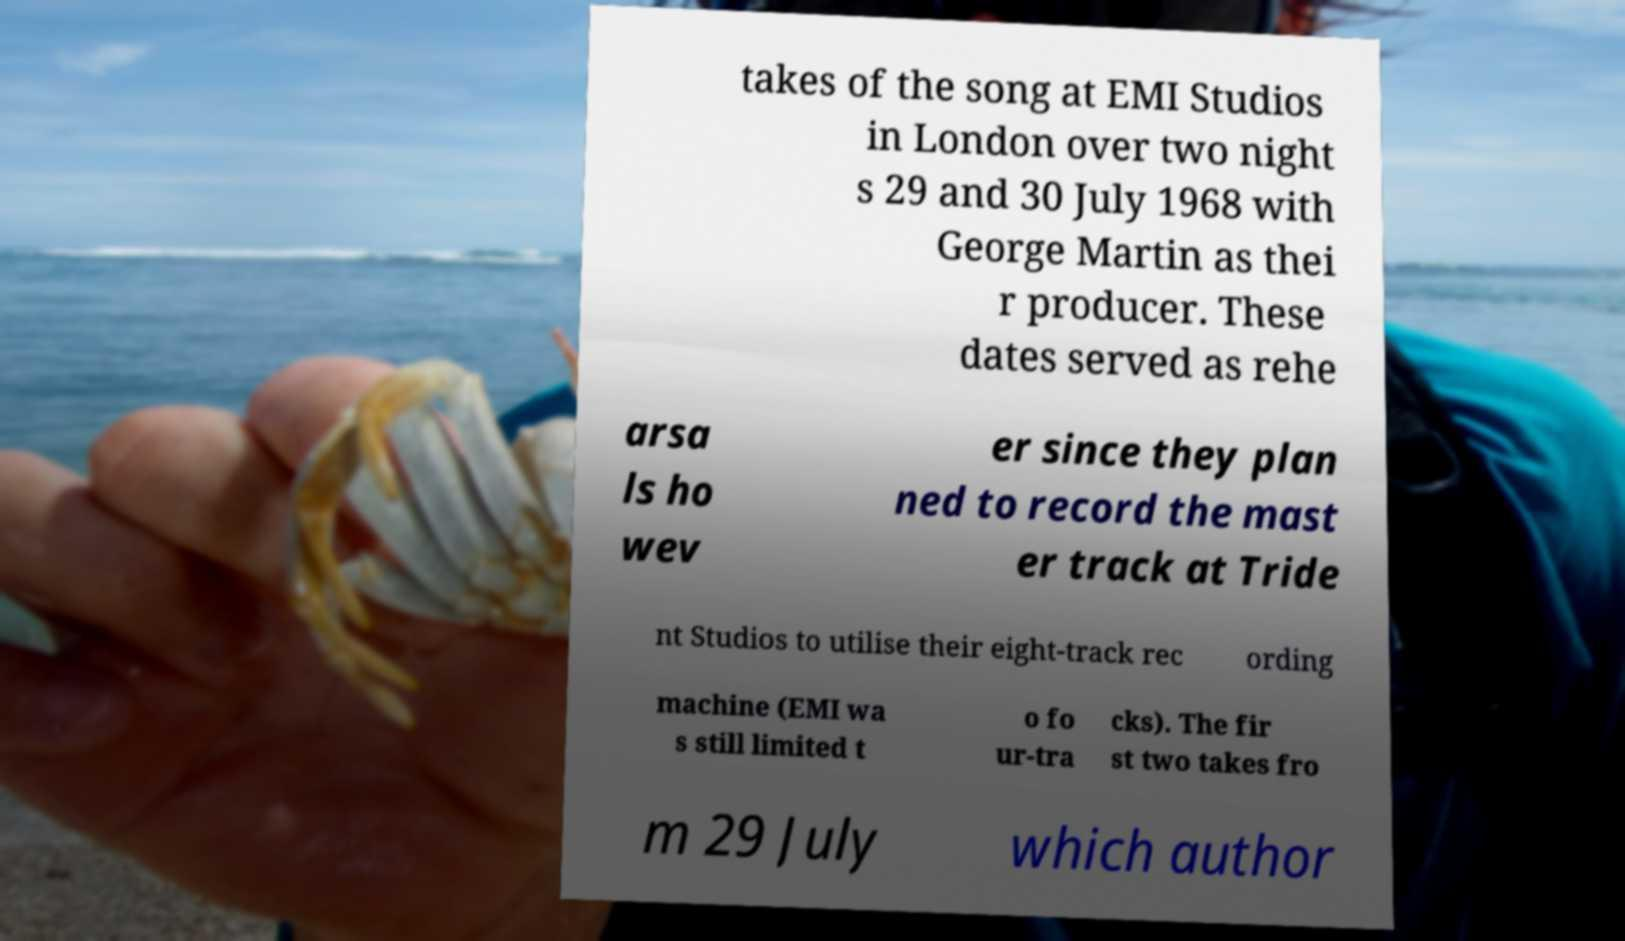Please identify and transcribe the text found in this image. takes of the song at EMI Studios in London over two night s 29 and 30 July 1968 with George Martin as thei r producer. These dates served as rehe arsa ls ho wev er since they plan ned to record the mast er track at Tride nt Studios to utilise their eight-track rec ording machine (EMI wa s still limited t o fo ur-tra cks). The fir st two takes fro m 29 July which author 